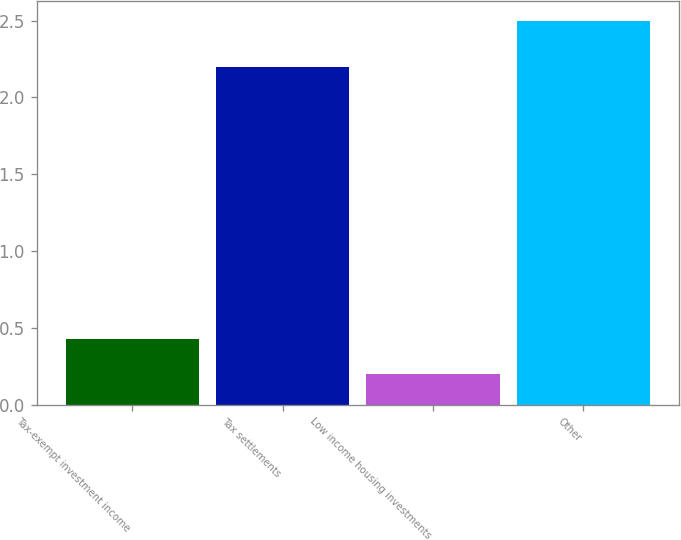<chart> <loc_0><loc_0><loc_500><loc_500><bar_chart><fcel>Tax-exempt investment income<fcel>Tax settlements<fcel>Low income housing investments<fcel>Other<nl><fcel>0.43<fcel>2.2<fcel>0.2<fcel>2.5<nl></chart> 